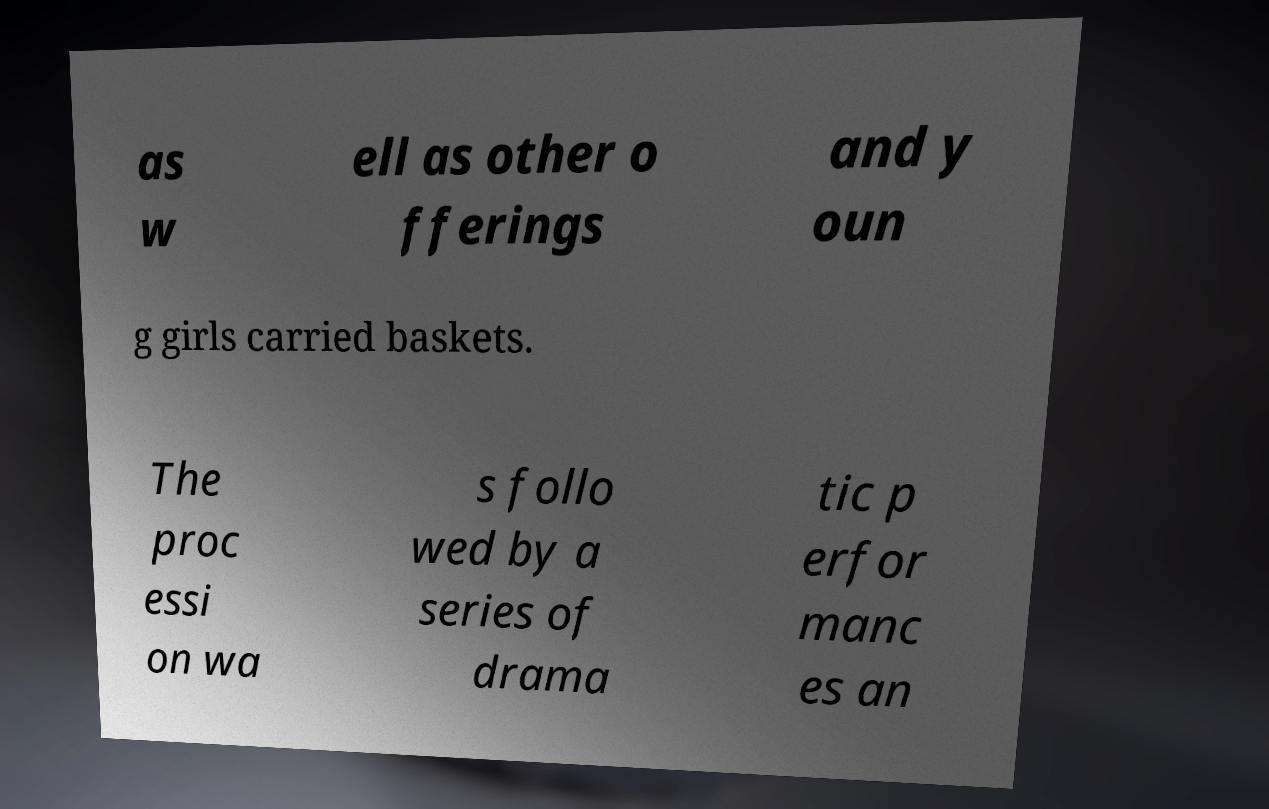Could you extract and type out the text from this image? as w ell as other o fferings and y oun g girls carried baskets. The proc essi on wa s follo wed by a series of drama tic p erfor manc es an 